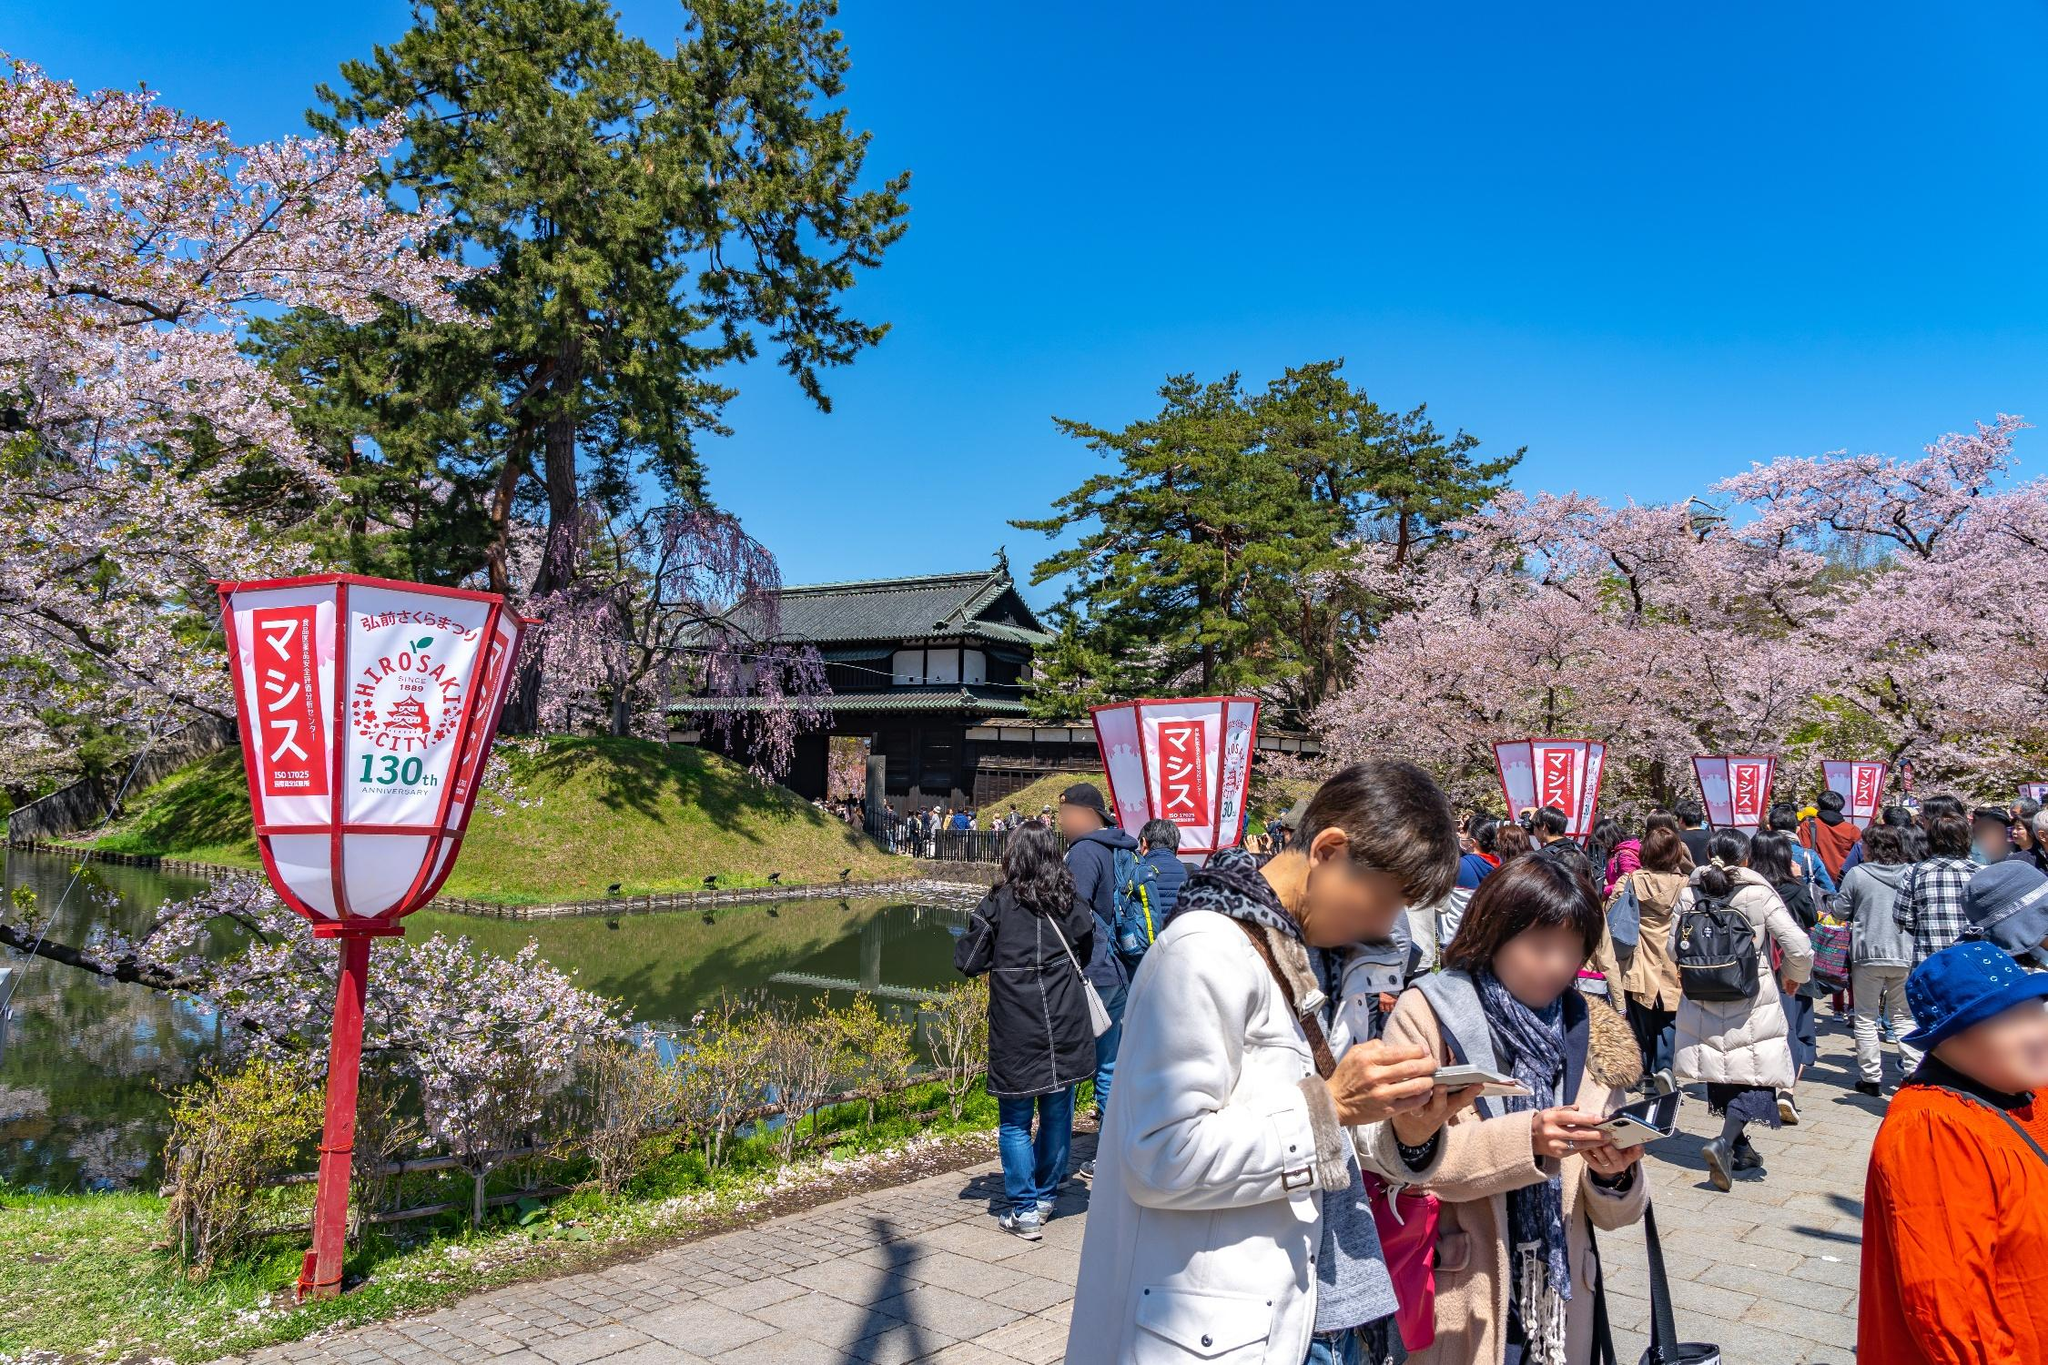What cultural significance do the lanterns hold? The red lanterns in the image are not just decorative; they hold cultural significance. In Japan, these lanterns, known as 'akachōchin,' are commonly used during festivals and celebrations. They symbolize joy and festivity. Here, they also serve a practical purpose of lighting the paths during the evening, allowing the festivities to continue after dusk. The writing on the lanterns often carries the names of sponsors or the festival itself, adding to the community spirit. 